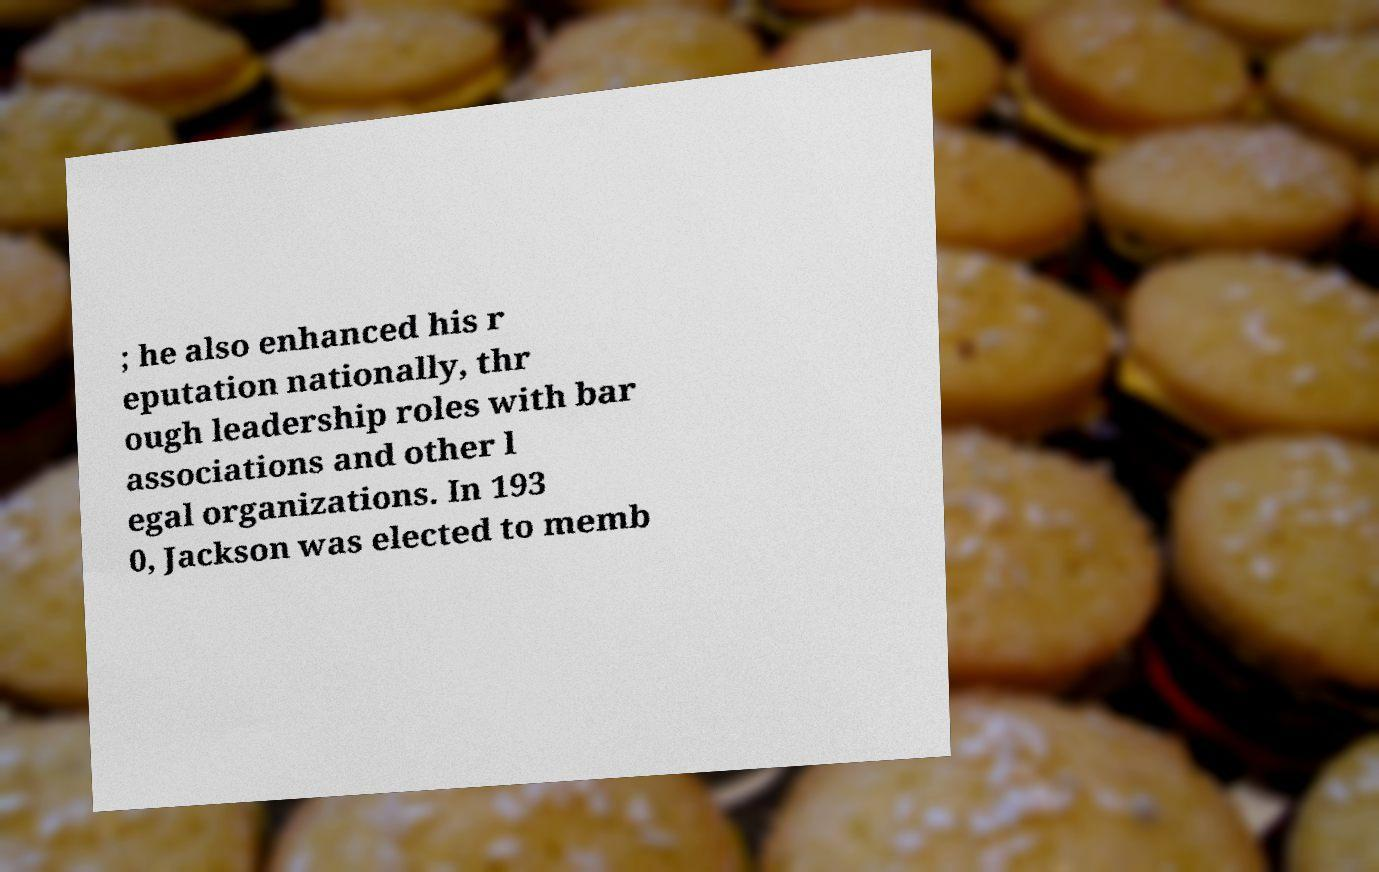What messages or text are displayed in this image? I need them in a readable, typed format. ; he also enhanced his r eputation nationally, thr ough leadership roles with bar associations and other l egal organizations. In 193 0, Jackson was elected to memb 